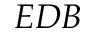<formula> <loc_0><loc_0><loc_500><loc_500>E D B</formula> 